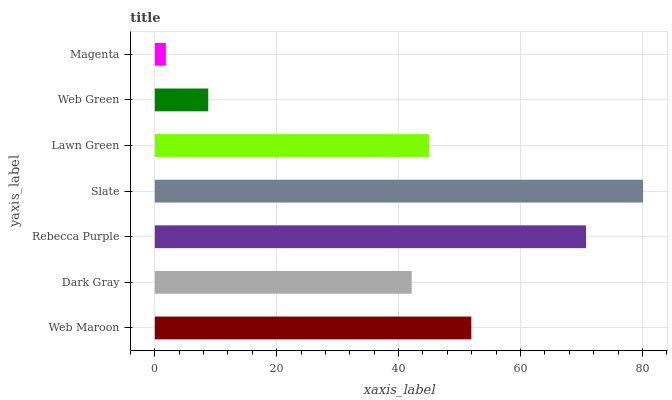Is Magenta the minimum?
Answer yes or no. Yes. Is Slate the maximum?
Answer yes or no. Yes. Is Dark Gray the minimum?
Answer yes or no. No. Is Dark Gray the maximum?
Answer yes or no. No. Is Web Maroon greater than Dark Gray?
Answer yes or no. Yes. Is Dark Gray less than Web Maroon?
Answer yes or no. Yes. Is Dark Gray greater than Web Maroon?
Answer yes or no. No. Is Web Maroon less than Dark Gray?
Answer yes or no. No. Is Lawn Green the high median?
Answer yes or no. Yes. Is Lawn Green the low median?
Answer yes or no. Yes. Is Web Maroon the high median?
Answer yes or no. No. Is Rebecca Purple the low median?
Answer yes or no. No. 